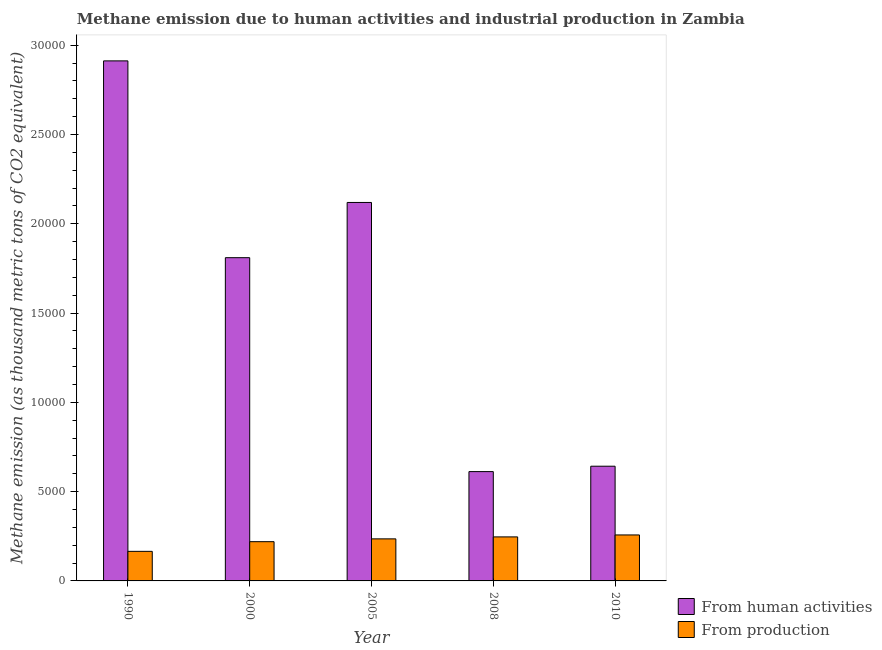Are the number of bars per tick equal to the number of legend labels?
Make the answer very short. Yes. Are the number of bars on each tick of the X-axis equal?
Make the answer very short. Yes. In how many cases, is the number of bars for a given year not equal to the number of legend labels?
Make the answer very short. 0. What is the amount of emissions generated from industries in 2010?
Provide a short and direct response. 2574.7. Across all years, what is the maximum amount of emissions generated from industries?
Offer a terse response. 2574.7. Across all years, what is the minimum amount of emissions generated from industries?
Ensure brevity in your answer.  1655.8. In which year was the amount of emissions from human activities minimum?
Your answer should be very brief. 2008. What is the total amount of emissions from human activities in the graph?
Your answer should be very brief. 8.10e+04. What is the difference between the amount of emissions from human activities in 2000 and that in 2008?
Ensure brevity in your answer.  1.20e+04. What is the difference between the amount of emissions generated from industries in 2000 and the amount of emissions from human activities in 2005?
Offer a very short reply. -157.5. What is the average amount of emissions from human activities per year?
Your response must be concise. 1.62e+04. In how many years, is the amount of emissions generated from industries greater than 16000 thousand metric tons?
Offer a very short reply. 0. What is the ratio of the amount of emissions generated from industries in 2000 to that in 2008?
Offer a very short reply. 0.89. Is the difference between the amount of emissions from human activities in 1990 and 2005 greater than the difference between the amount of emissions generated from industries in 1990 and 2005?
Your response must be concise. No. What is the difference between the highest and the second highest amount of emissions from human activities?
Make the answer very short. 7927.7. What is the difference between the highest and the lowest amount of emissions from human activities?
Make the answer very short. 2.30e+04. In how many years, is the amount of emissions from human activities greater than the average amount of emissions from human activities taken over all years?
Offer a very short reply. 3. What does the 1st bar from the left in 2000 represents?
Offer a terse response. From human activities. What does the 1st bar from the right in 1990 represents?
Offer a very short reply. From production. How many bars are there?
Give a very brief answer. 10. Are all the bars in the graph horizontal?
Offer a very short reply. No. What is the difference between two consecutive major ticks on the Y-axis?
Your answer should be compact. 5000. Where does the legend appear in the graph?
Give a very brief answer. Bottom right. How are the legend labels stacked?
Keep it short and to the point. Vertical. What is the title of the graph?
Make the answer very short. Methane emission due to human activities and industrial production in Zambia. What is the label or title of the Y-axis?
Your response must be concise. Methane emission (as thousand metric tons of CO2 equivalent). What is the Methane emission (as thousand metric tons of CO2 equivalent) in From human activities in 1990?
Your answer should be very brief. 2.91e+04. What is the Methane emission (as thousand metric tons of CO2 equivalent) in From production in 1990?
Give a very brief answer. 1655.8. What is the Methane emission (as thousand metric tons of CO2 equivalent) of From human activities in 2000?
Keep it short and to the point. 1.81e+04. What is the Methane emission (as thousand metric tons of CO2 equivalent) in From production in 2000?
Offer a very short reply. 2197.5. What is the Methane emission (as thousand metric tons of CO2 equivalent) in From human activities in 2005?
Your answer should be compact. 2.12e+04. What is the Methane emission (as thousand metric tons of CO2 equivalent) of From production in 2005?
Give a very brief answer. 2355. What is the Methane emission (as thousand metric tons of CO2 equivalent) of From human activities in 2008?
Provide a succinct answer. 6121.2. What is the Methane emission (as thousand metric tons of CO2 equivalent) in From production in 2008?
Your answer should be compact. 2464.9. What is the Methane emission (as thousand metric tons of CO2 equivalent) in From human activities in 2010?
Ensure brevity in your answer.  6422.9. What is the Methane emission (as thousand metric tons of CO2 equivalent) of From production in 2010?
Your answer should be very brief. 2574.7. Across all years, what is the maximum Methane emission (as thousand metric tons of CO2 equivalent) of From human activities?
Provide a succinct answer. 2.91e+04. Across all years, what is the maximum Methane emission (as thousand metric tons of CO2 equivalent) in From production?
Ensure brevity in your answer.  2574.7. Across all years, what is the minimum Methane emission (as thousand metric tons of CO2 equivalent) of From human activities?
Offer a terse response. 6121.2. Across all years, what is the minimum Methane emission (as thousand metric tons of CO2 equivalent) of From production?
Provide a succinct answer. 1655.8. What is the total Methane emission (as thousand metric tons of CO2 equivalent) in From human activities in the graph?
Your answer should be very brief. 8.10e+04. What is the total Methane emission (as thousand metric tons of CO2 equivalent) in From production in the graph?
Offer a very short reply. 1.12e+04. What is the difference between the Methane emission (as thousand metric tons of CO2 equivalent) of From human activities in 1990 and that in 2000?
Give a very brief answer. 1.10e+04. What is the difference between the Methane emission (as thousand metric tons of CO2 equivalent) of From production in 1990 and that in 2000?
Keep it short and to the point. -541.7. What is the difference between the Methane emission (as thousand metric tons of CO2 equivalent) in From human activities in 1990 and that in 2005?
Offer a very short reply. 7927.7. What is the difference between the Methane emission (as thousand metric tons of CO2 equivalent) of From production in 1990 and that in 2005?
Ensure brevity in your answer.  -699.2. What is the difference between the Methane emission (as thousand metric tons of CO2 equivalent) of From human activities in 1990 and that in 2008?
Your response must be concise. 2.30e+04. What is the difference between the Methane emission (as thousand metric tons of CO2 equivalent) of From production in 1990 and that in 2008?
Provide a short and direct response. -809.1. What is the difference between the Methane emission (as thousand metric tons of CO2 equivalent) of From human activities in 1990 and that in 2010?
Your response must be concise. 2.27e+04. What is the difference between the Methane emission (as thousand metric tons of CO2 equivalent) in From production in 1990 and that in 2010?
Your answer should be compact. -918.9. What is the difference between the Methane emission (as thousand metric tons of CO2 equivalent) of From human activities in 2000 and that in 2005?
Provide a short and direct response. -3091.8. What is the difference between the Methane emission (as thousand metric tons of CO2 equivalent) in From production in 2000 and that in 2005?
Make the answer very short. -157.5. What is the difference between the Methane emission (as thousand metric tons of CO2 equivalent) of From human activities in 2000 and that in 2008?
Make the answer very short. 1.20e+04. What is the difference between the Methane emission (as thousand metric tons of CO2 equivalent) of From production in 2000 and that in 2008?
Your response must be concise. -267.4. What is the difference between the Methane emission (as thousand metric tons of CO2 equivalent) in From human activities in 2000 and that in 2010?
Offer a very short reply. 1.17e+04. What is the difference between the Methane emission (as thousand metric tons of CO2 equivalent) in From production in 2000 and that in 2010?
Offer a very short reply. -377.2. What is the difference between the Methane emission (as thousand metric tons of CO2 equivalent) of From human activities in 2005 and that in 2008?
Your response must be concise. 1.51e+04. What is the difference between the Methane emission (as thousand metric tons of CO2 equivalent) of From production in 2005 and that in 2008?
Ensure brevity in your answer.  -109.9. What is the difference between the Methane emission (as thousand metric tons of CO2 equivalent) of From human activities in 2005 and that in 2010?
Your answer should be very brief. 1.48e+04. What is the difference between the Methane emission (as thousand metric tons of CO2 equivalent) of From production in 2005 and that in 2010?
Your answer should be very brief. -219.7. What is the difference between the Methane emission (as thousand metric tons of CO2 equivalent) in From human activities in 2008 and that in 2010?
Your answer should be compact. -301.7. What is the difference between the Methane emission (as thousand metric tons of CO2 equivalent) of From production in 2008 and that in 2010?
Keep it short and to the point. -109.8. What is the difference between the Methane emission (as thousand metric tons of CO2 equivalent) in From human activities in 1990 and the Methane emission (as thousand metric tons of CO2 equivalent) in From production in 2000?
Provide a short and direct response. 2.69e+04. What is the difference between the Methane emission (as thousand metric tons of CO2 equivalent) in From human activities in 1990 and the Methane emission (as thousand metric tons of CO2 equivalent) in From production in 2005?
Your answer should be compact. 2.68e+04. What is the difference between the Methane emission (as thousand metric tons of CO2 equivalent) in From human activities in 1990 and the Methane emission (as thousand metric tons of CO2 equivalent) in From production in 2008?
Your answer should be very brief. 2.67e+04. What is the difference between the Methane emission (as thousand metric tons of CO2 equivalent) of From human activities in 1990 and the Methane emission (as thousand metric tons of CO2 equivalent) of From production in 2010?
Provide a short and direct response. 2.65e+04. What is the difference between the Methane emission (as thousand metric tons of CO2 equivalent) of From human activities in 2000 and the Methane emission (as thousand metric tons of CO2 equivalent) of From production in 2005?
Keep it short and to the point. 1.57e+04. What is the difference between the Methane emission (as thousand metric tons of CO2 equivalent) in From human activities in 2000 and the Methane emission (as thousand metric tons of CO2 equivalent) in From production in 2008?
Provide a succinct answer. 1.56e+04. What is the difference between the Methane emission (as thousand metric tons of CO2 equivalent) in From human activities in 2000 and the Methane emission (as thousand metric tons of CO2 equivalent) in From production in 2010?
Offer a very short reply. 1.55e+04. What is the difference between the Methane emission (as thousand metric tons of CO2 equivalent) in From human activities in 2005 and the Methane emission (as thousand metric tons of CO2 equivalent) in From production in 2008?
Offer a very short reply. 1.87e+04. What is the difference between the Methane emission (as thousand metric tons of CO2 equivalent) in From human activities in 2005 and the Methane emission (as thousand metric tons of CO2 equivalent) in From production in 2010?
Ensure brevity in your answer.  1.86e+04. What is the difference between the Methane emission (as thousand metric tons of CO2 equivalent) in From human activities in 2008 and the Methane emission (as thousand metric tons of CO2 equivalent) in From production in 2010?
Offer a very short reply. 3546.5. What is the average Methane emission (as thousand metric tons of CO2 equivalent) in From human activities per year?
Make the answer very short. 1.62e+04. What is the average Methane emission (as thousand metric tons of CO2 equivalent) in From production per year?
Provide a succinct answer. 2249.58. In the year 1990, what is the difference between the Methane emission (as thousand metric tons of CO2 equivalent) in From human activities and Methane emission (as thousand metric tons of CO2 equivalent) in From production?
Offer a terse response. 2.75e+04. In the year 2000, what is the difference between the Methane emission (as thousand metric tons of CO2 equivalent) in From human activities and Methane emission (as thousand metric tons of CO2 equivalent) in From production?
Give a very brief answer. 1.59e+04. In the year 2005, what is the difference between the Methane emission (as thousand metric tons of CO2 equivalent) of From human activities and Methane emission (as thousand metric tons of CO2 equivalent) of From production?
Your answer should be very brief. 1.88e+04. In the year 2008, what is the difference between the Methane emission (as thousand metric tons of CO2 equivalent) in From human activities and Methane emission (as thousand metric tons of CO2 equivalent) in From production?
Keep it short and to the point. 3656.3. In the year 2010, what is the difference between the Methane emission (as thousand metric tons of CO2 equivalent) in From human activities and Methane emission (as thousand metric tons of CO2 equivalent) in From production?
Your response must be concise. 3848.2. What is the ratio of the Methane emission (as thousand metric tons of CO2 equivalent) of From human activities in 1990 to that in 2000?
Keep it short and to the point. 1.61. What is the ratio of the Methane emission (as thousand metric tons of CO2 equivalent) of From production in 1990 to that in 2000?
Offer a terse response. 0.75. What is the ratio of the Methane emission (as thousand metric tons of CO2 equivalent) in From human activities in 1990 to that in 2005?
Give a very brief answer. 1.37. What is the ratio of the Methane emission (as thousand metric tons of CO2 equivalent) of From production in 1990 to that in 2005?
Keep it short and to the point. 0.7. What is the ratio of the Methane emission (as thousand metric tons of CO2 equivalent) in From human activities in 1990 to that in 2008?
Your response must be concise. 4.76. What is the ratio of the Methane emission (as thousand metric tons of CO2 equivalent) of From production in 1990 to that in 2008?
Make the answer very short. 0.67. What is the ratio of the Methane emission (as thousand metric tons of CO2 equivalent) of From human activities in 1990 to that in 2010?
Give a very brief answer. 4.53. What is the ratio of the Methane emission (as thousand metric tons of CO2 equivalent) in From production in 1990 to that in 2010?
Your answer should be compact. 0.64. What is the ratio of the Methane emission (as thousand metric tons of CO2 equivalent) of From human activities in 2000 to that in 2005?
Give a very brief answer. 0.85. What is the ratio of the Methane emission (as thousand metric tons of CO2 equivalent) in From production in 2000 to that in 2005?
Your answer should be compact. 0.93. What is the ratio of the Methane emission (as thousand metric tons of CO2 equivalent) of From human activities in 2000 to that in 2008?
Your response must be concise. 2.96. What is the ratio of the Methane emission (as thousand metric tons of CO2 equivalent) of From production in 2000 to that in 2008?
Make the answer very short. 0.89. What is the ratio of the Methane emission (as thousand metric tons of CO2 equivalent) in From human activities in 2000 to that in 2010?
Offer a very short reply. 2.82. What is the ratio of the Methane emission (as thousand metric tons of CO2 equivalent) of From production in 2000 to that in 2010?
Provide a succinct answer. 0.85. What is the ratio of the Methane emission (as thousand metric tons of CO2 equivalent) of From human activities in 2005 to that in 2008?
Your response must be concise. 3.46. What is the ratio of the Methane emission (as thousand metric tons of CO2 equivalent) of From production in 2005 to that in 2008?
Offer a very short reply. 0.96. What is the ratio of the Methane emission (as thousand metric tons of CO2 equivalent) in From human activities in 2005 to that in 2010?
Make the answer very short. 3.3. What is the ratio of the Methane emission (as thousand metric tons of CO2 equivalent) in From production in 2005 to that in 2010?
Offer a very short reply. 0.91. What is the ratio of the Methane emission (as thousand metric tons of CO2 equivalent) in From human activities in 2008 to that in 2010?
Offer a very short reply. 0.95. What is the ratio of the Methane emission (as thousand metric tons of CO2 equivalent) in From production in 2008 to that in 2010?
Provide a succinct answer. 0.96. What is the difference between the highest and the second highest Methane emission (as thousand metric tons of CO2 equivalent) of From human activities?
Ensure brevity in your answer.  7927.7. What is the difference between the highest and the second highest Methane emission (as thousand metric tons of CO2 equivalent) of From production?
Offer a terse response. 109.8. What is the difference between the highest and the lowest Methane emission (as thousand metric tons of CO2 equivalent) in From human activities?
Keep it short and to the point. 2.30e+04. What is the difference between the highest and the lowest Methane emission (as thousand metric tons of CO2 equivalent) of From production?
Offer a very short reply. 918.9. 